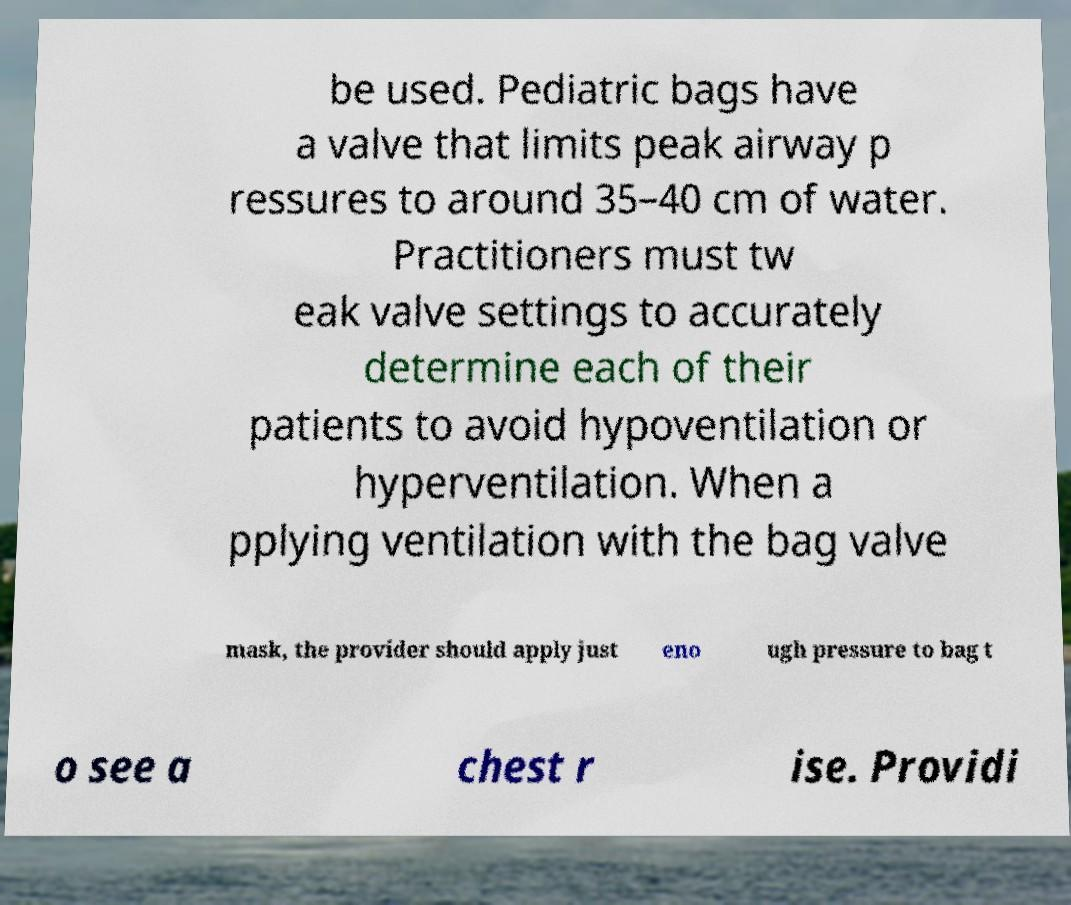I need the written content from this picture converted into text. Can you do that? be used. Pediatric bags have a valve that limits peak airway p ressures to around 35–40 cm of water. Practitioners must tw eak valve settings to accurately determine each of their patients to avoid hypoventilation or hyperventilation. When a pplying ventilation with the bag valve mask, the provider should apply just eno ugh pressure to bag t o see a chest r ise. Providi 